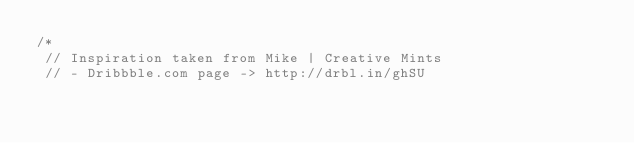<code> <loc_0><loc_0><loc_500><loc_500><_CSS_>/*
 // Inspiration taken from Mike | Creative Mints
 // - Dribbble.com page -> http://drbl.in/ghSU
 </code> 